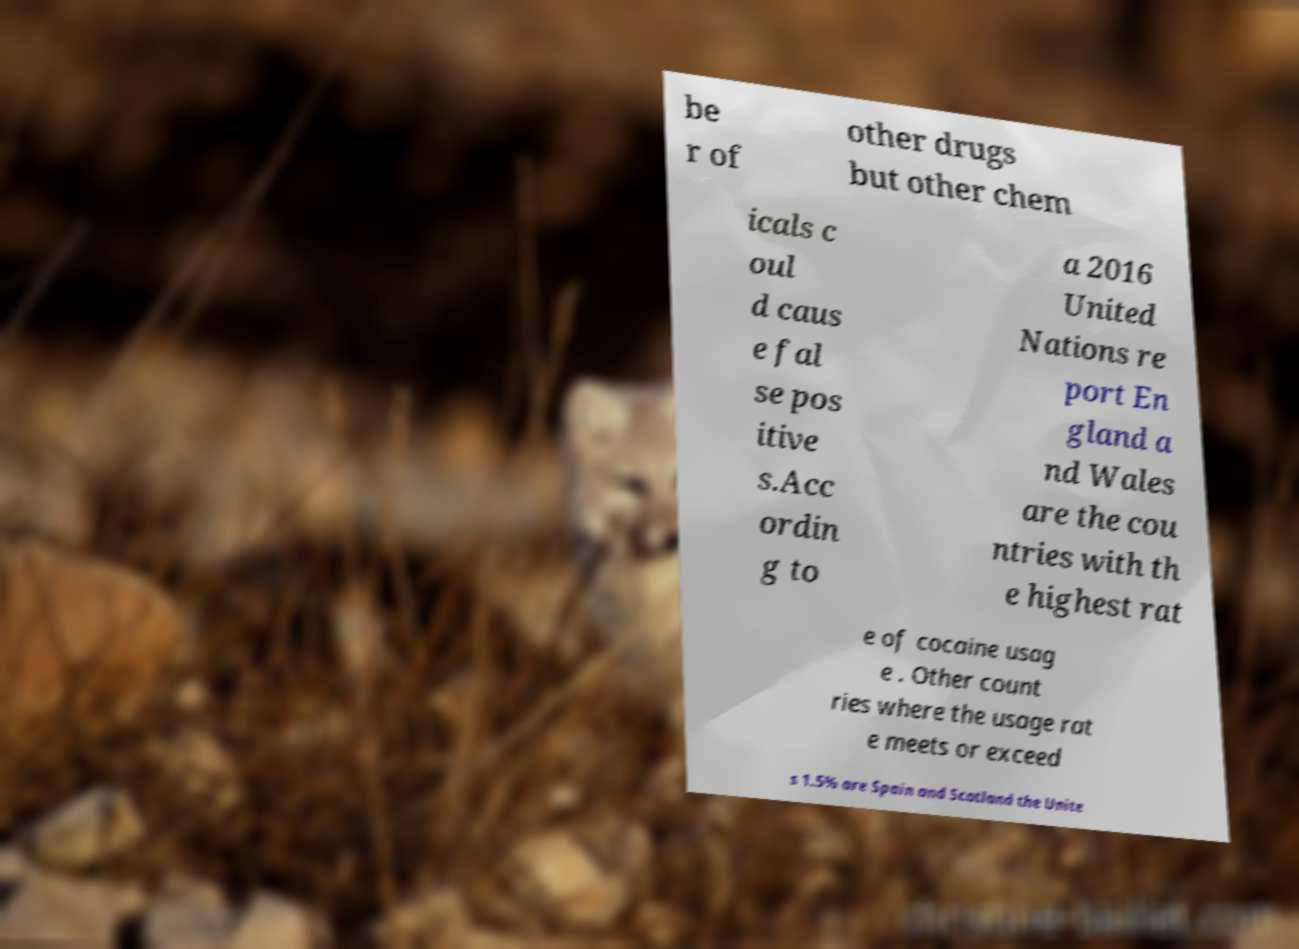Could you assist in decoding the text presented in this image and type it out clearly? be r of other drugs but other chem icals c oul d caus e fal se pos itive s.Acc ordin g to a 2016 United Nations re port En gland a nd Wales are the cou ntries with th e highest rat e of cocaine usag e . Other count ries where the usage rat e meets or exceed s 1.5% are Spain and Scotland the Unite 